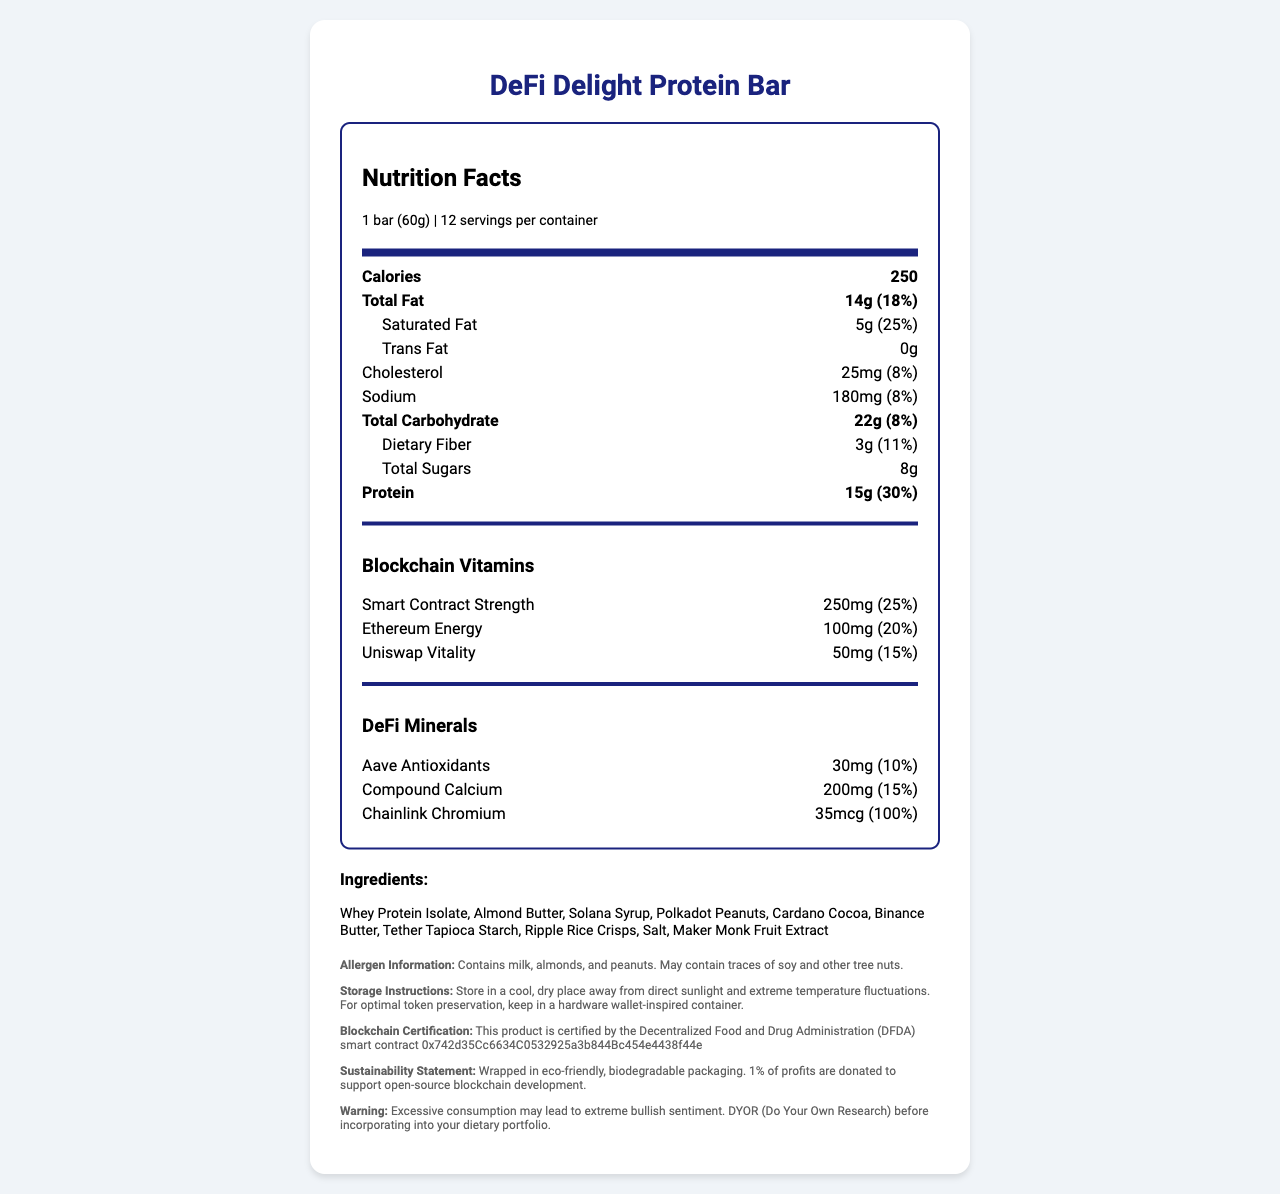who certifies the DeFi Delight Protein Bar? The document states that the product is certified by the Decentralized Food and Drug Administration (DFDA) smart contract 0x742d35Cc6634C0532925a3b844Bc454e4438f44e.
Answer: The Decentralized Food and Drug Administration (DFDA) what warning is given about excessive consumption of the protein bar? The document includes a warning about excessive consumption leading to extreme bullish sentiment and advises to do your own research.
Answer: Excessive consumption may lead to extreme bullish sentiment. DYOR (Do Your Own Research) before incorporating into your dietary portfolio. how many servings are in one container of the DeFi Delight Protein Bar? According to the document, there are 12 servings per container.
Answer: 12 what is the daily value percentage for Compound Calcium in one bar? The document specifies that Compound Calcium has a daily value of 15%.
Answer: 15% what are the storage instructions for the DeFi Delight Protein Bar? The document provides detailed storage instructions suggesting a cool, dry place and even a hardware wallet-inspired container for optimal token preservation.
Answer: Store in a cool, dry place away from direct sunlight and extreme temperature fluctuations. For optimal token preservation, keep in a hardware wallet-inspired container. which of the following is not an ingredient in the DeFi Delight Protein Bar? A. Whey Protein Isolate B. Solana Syrup C. Bitcoin Butter D. Maker Monk Fruit Extract The listed ingredients include Whey Protein Isolate, Solana Syrup, and Maker Monk Fruit Extract, but not Bitcoin Butter.
Answer: C. Bitcoin Butter what is the main source of protein in the DeFi Delight Protein Bar? A. Almond Butter B. Whey Protein Isolate C. Polkadot Peanuts D. Ripple Rice Crisps The primary ingredient and main source of protein is Whey Protein Isolate.
Answer: B. Whey Protein Isolate does the DeFi Delight Protein Bar contain any allergens? The allergen information states that the bar contains milk, almonds, and peanuts and may contain traces of soy and other tree nuts.
Answer: Yes describe the main components and features of the DeFi Delight Protein Bar. The document details the calories, fats, proteins, blockchain-related nutrients, certification by the DFDA, and eco-friendly packaging, providing a comprehensive overview of the product's composition and features.
Answer: The DeFi Delight Protein Bar contains 250 calories per serving with notable nutrients such as 14g of total fat, 15g of protein, and unique blockchain-related ingredients including Smart Contract Strength, Ethereum Energy, and DeFi Minerals like Aave Antioxidants and Chainlink Chromium. It is certified by the DFDA and packaged in eco-friendly materials. what is the exact amount of Trans Fat in the DeFi Delight Protein Bar? While the document states that the Trans Fat is 0g, we cannot verify its exactness as it is stated as 0g, which might not provide a precise measurement.
Answer: Cannot be determined 